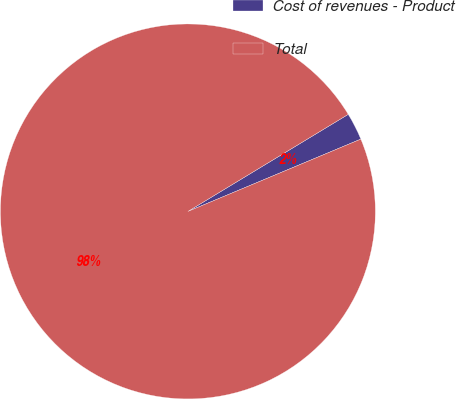Convert chart. <chart><loc_0><loc_0><loc_500><loc_500><pie_chart><fcel>Cost of revenues - Product<fcel>Total<nl><fcel>2.36%<fcel>97.64%<nl></chart> 